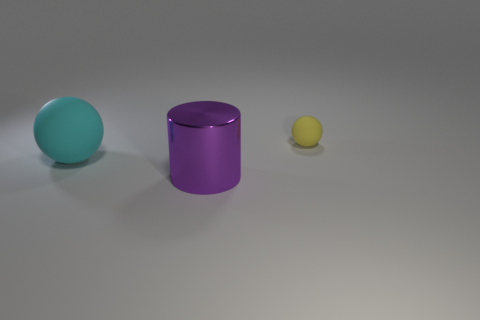Add 3 yellow matte objects. How many objects exist? 6 Subtract all cylinders. How many objects are left? 2 Add 1 cyan rubber balls. How many cyan rubber balls are left? 2 Add 3 metal blocks. How many metal blocks exist? 3 Subtract 0 red balls. How many objects are left? 3 Subtract all cyan objects. Subtract all cyan spheres. How many objects are left? 1 